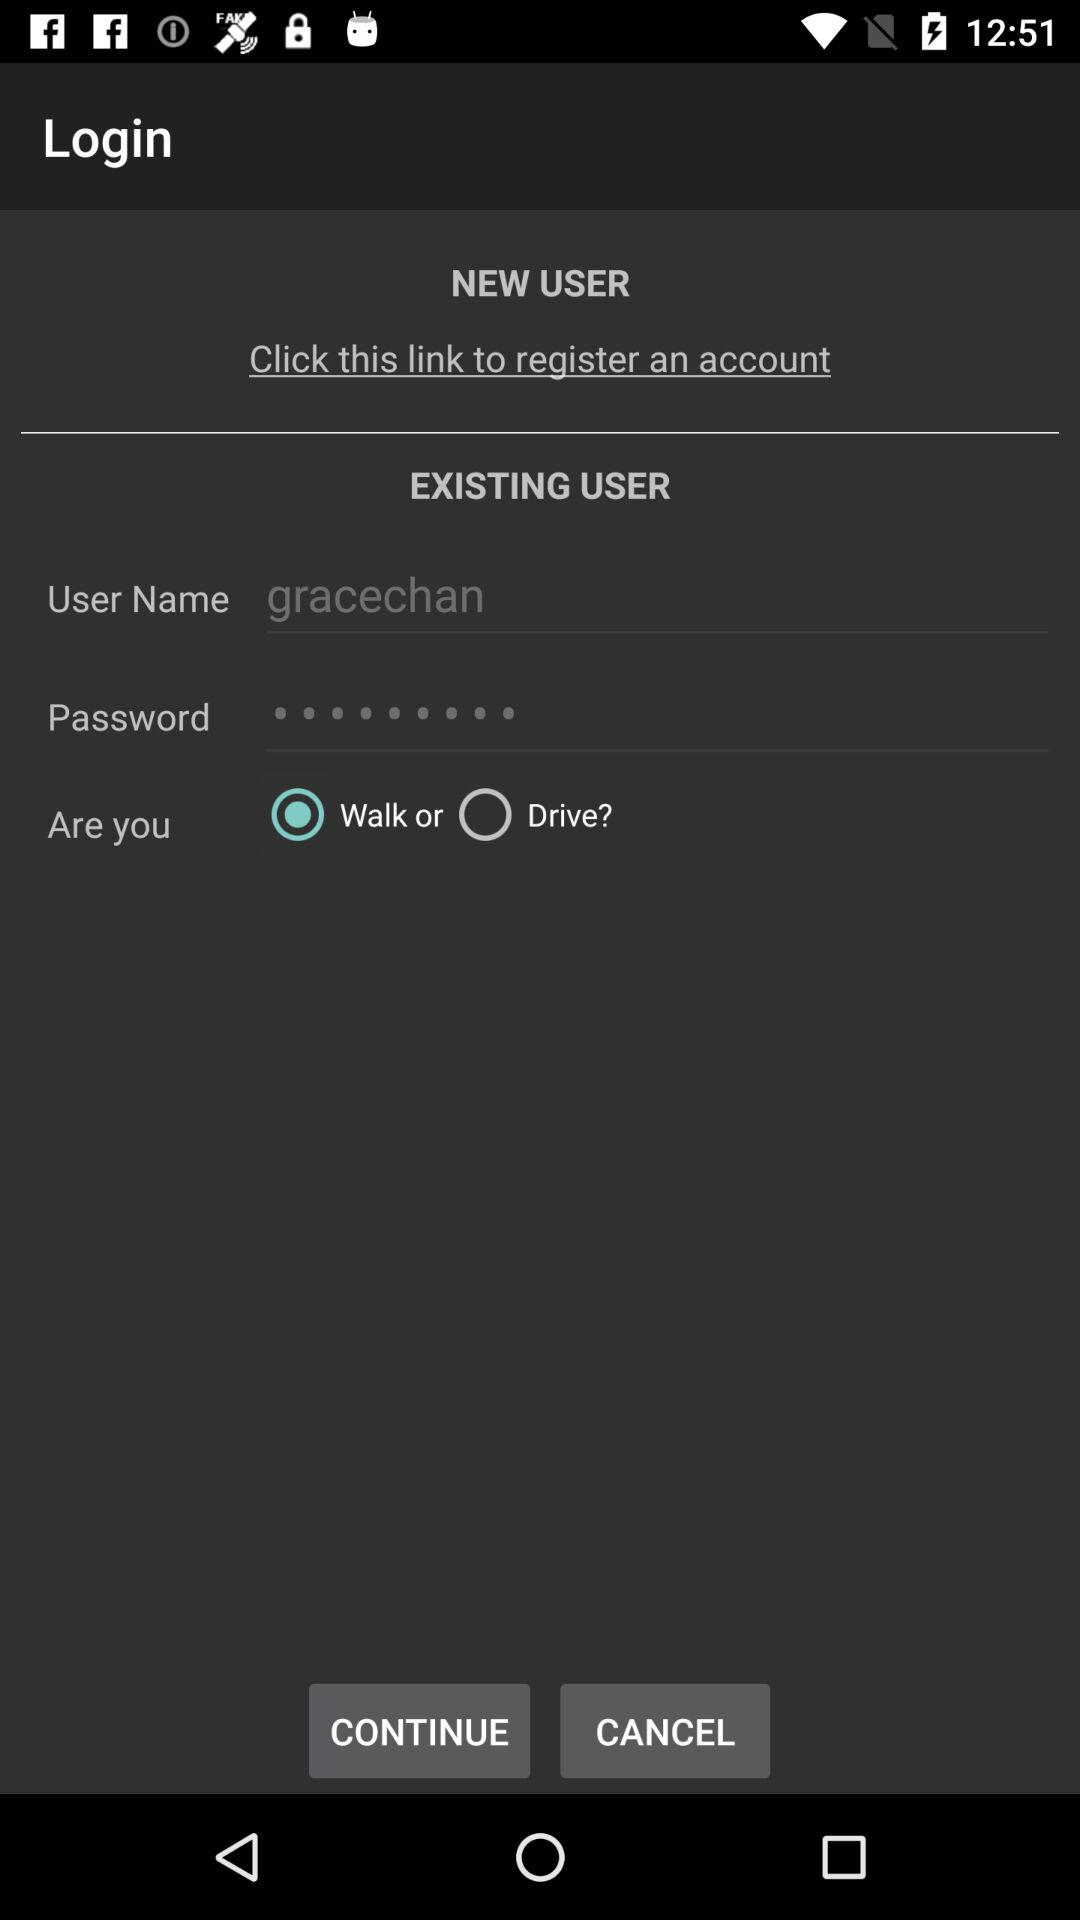Which option is selected "Walk" or "Drive"? The selected option is "Walk". 